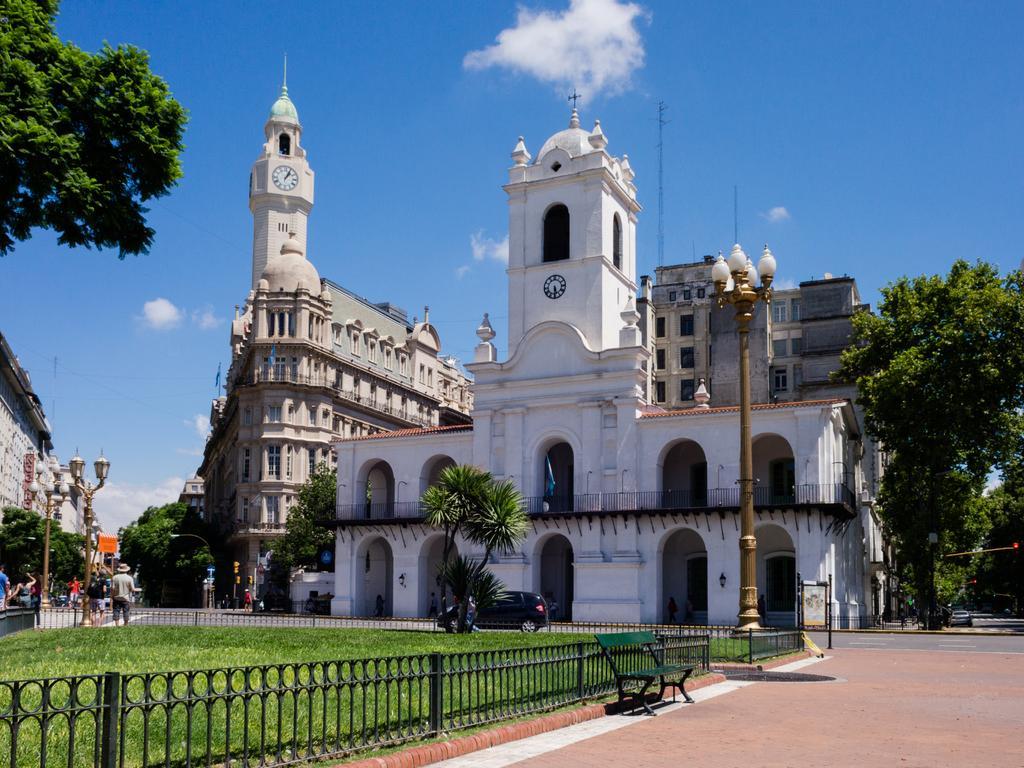Describe this image in one or two sentences. In this image I can see a bench. On the left side I can see the rail and the grass. In the background, I can see the buildings, trees and clouds in the sky. 